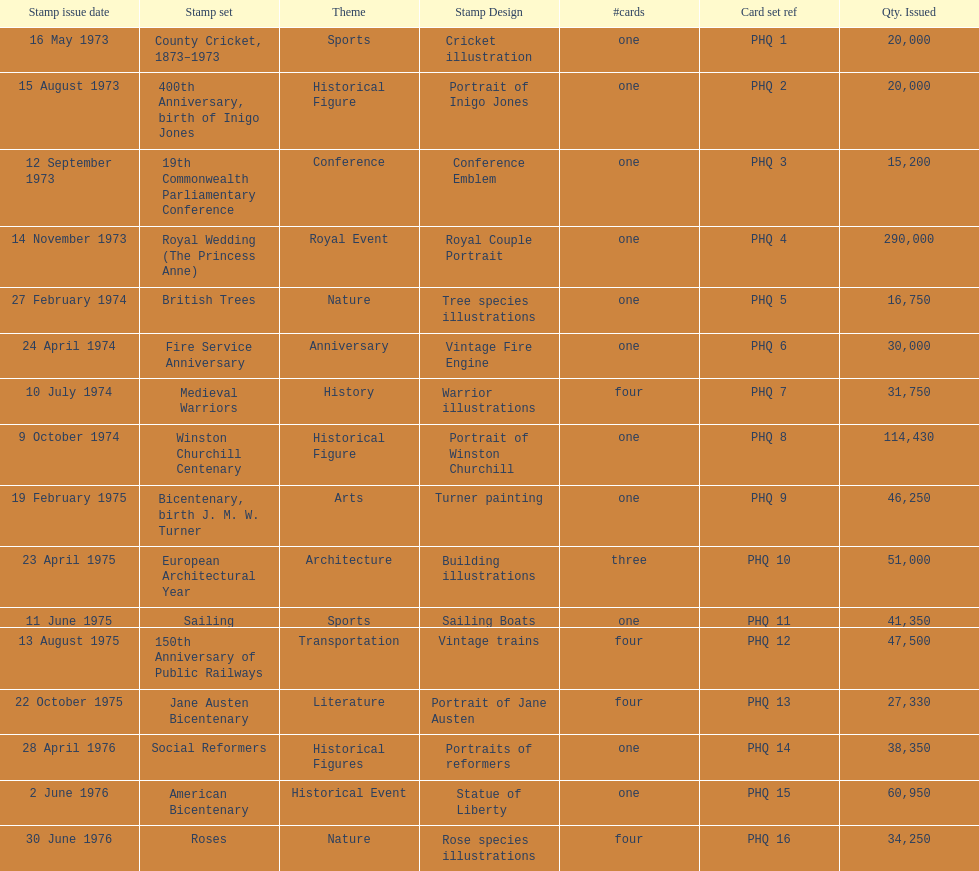Provide a list of every 200-year anniversary stamp set. Bicentenary, birth J. M. W. Turner, Jane Austen Bicentenary, American Bicentenary. 